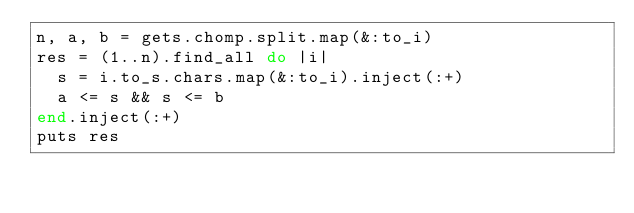<code> <loc_0><loc_0><loc_500><loc_500><_Ruby_>n, a, b = gets.chomp.split.map(&:to_i)
res = (1..n).find_all do |i|
  s = i.to_s.chars.map(&:to_i).inject(:+)
  a <= s && s <= b
end.inject(:+)
puts res</code> 